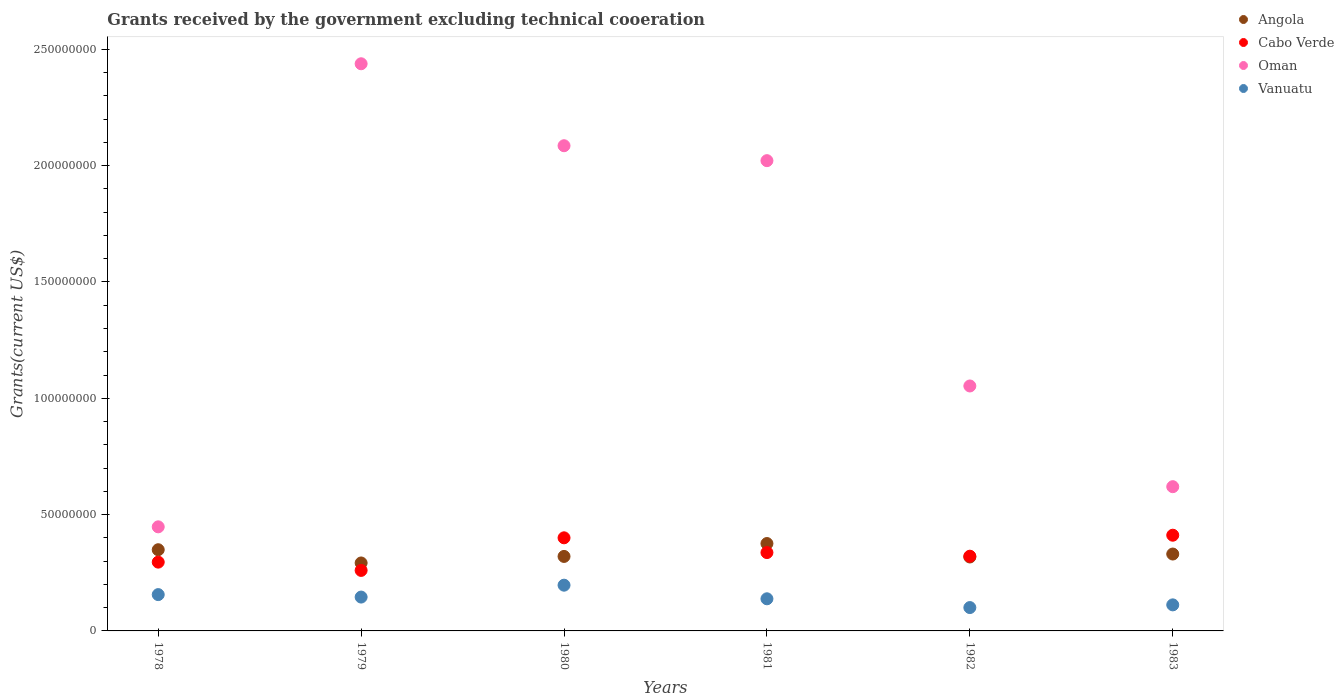What is the total grants received by the government in Vanuatu in 1979?
Give a very brief answer. 1.46e+07. Across all years, what is the maximum total grants received by the government in Vanuatu?
Keep it short and to the point. 1.97e+07. Across all years, what is the minimum total grants received by the government in Vanuatu?
Provide a short and direct response. 1.00e+07. In which year was the total grants received by the government in Cabo Verde maximum?
Your response must be concise. 1983. In which year was the total grants received by the government in Oman minimum?
Give a very brief answer. 1978. What is the total total grants received by the government in Vanuatu in the graph?
Ensure brevity in your answer.  8.49e+07. What is the difference between the total grants received by the government in Angola in 1979 and that in 1982?
Ensure brevity in your answer.  -2.57e+06. What is the difference between the total grants received by the government in Vanuatu in 1983 and the total grants received by the government in Oman in 1980?
Offer a terse response. -1.97e+08. What is the average total grants received by the government in Angola per year?
Provide a succinct answer. 3.31e+07. In the year 1979, what is the difference between the total grants received by the government in Vanuatu and total grants received by the government in Angola?
Give a very brief answer. -1.47e+07. In how many years, is the total grants received by the government in Angola greater than 140000000 US$?
Provide a short and direct response. 0. What is the ratio of the total grants received by the government in Oman in 1979 to that in 1981?
Your answer should be very brief. 1.21. Is the difference between the total grants received by the government in Vanuatu in 1980 and 1983 greater than the difference between the total grants received by the government in Angola in 1980 and 1983?
Provide a short and direct response. Yes. What is the difference between the highest and the second highest total grants received by the government in Vanuatu?
Provide a succinct answer. 4.05e+06. What is the difference between the highest and the lowest total grants received by the government in Vanuatu?
Your answer should be compact. 9.62e+06. In how many years, is the total grants received by the government in Oman greater than the average total grants received by the government in Oman taken over all years?
Give a very brief answer. 3. Is the sum of the total grants received by the government in Vanuatu in 1978 and 1982 greater than the maximum total grants received by the government in Cabo Verde across all years?
Your answer should be very brief. No. Is it the case that in every year, the sum of the total grants received by the government in Oman and total grants received by the government in Vanuatu  is greater than the total grants received by the government in Angola?
Give a very brief answer. Yes. How many dotlines are there?
Offer a very short reply. 4. How many years are there in the graph?
Keep it short and to the point. 6. Are the values on the major ticks of Y-axis written in scientific E-notation?
Provide a short and direct response. No. Does the graph contain grids?
Your answer should be very brief. No. What is the title of the graph?
Make the answer very short. Grants received by the government excluding technical cooeration. What is the label or title of the Y-axis?
Offer a terse response. Grants(current US$). What is the Grants(current US$) of Angola in 1978?
Keep it short and to the point. 3.49e+07. What is the Grants(current US$) of Cabo Verde in 1978?
Provide a succinct answer. 2.96e+07. What is the Grants(current US$) of Oman in 1978?
Your answer should be compact. 4.47e+07. What is the Grants(current US$) of Vanuatu in 1978?
Provide a succinct answer. 1.56e+07. What is the Grants(current US$) in Angola in 1979?
Your answer should be very brief. 2.92e+07. What is the Grants(current US$) of Cabo Verde in 1979?
Provide a short and direct response. 2.60e+07. What is the Grants(current US$) in Oman in 1979?
Keep it short and to the point. 2.44e+08. What is the Grants(current US$) of Vanuatu in 1979?
Your answer should be very brief. 1.46e+07. What is the Grants(current US$) in Angola in 1980?
Your answer should be compact. 3.20e+07. What is the Grants(current US$) in Cabo Verde in 1980?
Your answer should be compact. 4.00e+07. What is the Grants(current US$) in Oman in 1980?
Provide a succinct answer. 2.09e+08. What is the Grants(current US$) in Vanuatu in 1980?
Offer a terse response. 1.97e+07. What is the Grants(current US$) in Angola in 1981?
Your response must be concise. 3.76e+07. What is the Grants(current US$) in Cabo Verde in 1981?
Your answer should be very brief. 3.37e+07. What is the Grants(current US$) in Oman in 1981?
Ensure brevity in your answer.  2.02e+08. What is the Grants(current US$) of Vanuatu in 1981?
Provide a short and direct response. 1.38e+07. What is the Grants(current US$) of Angola in 1982?
Offer a very short reply. 3.18e+07. What is the Grants(current US$) in Cabo Verde in 1982?
Provide a short and direct response. 3.21e+07. What is the Grants(current US$) of Oman in 1982?
Your answer should be very brief. 1.05e+08. What is the Grants(current US$) of Vanuatu in 1982?
Your answer should be compact. 1.00e+07. What is the Grants(current US$) in Angola in 1983?
Your answer should be compact. 3.30e+07. What is the Grants(current US$) in Cabo Verde in 1983?
Offer a very short reply. 4.11e+07. What is the Grants(current US$) of Oman in 1983?
Provide a succinct answer. 6.20e+07. What is the Grants(current US$) of Vanuatu in 1983?
Provide a succinct answer. 1.12e+07. Across all years, what is the maximum Grants(current US$) in Angola?
Keep it short and to the point. 3.76e+07. Across all years, what is the maximum Grants(current US$) in Cabo Verde?
Make the answer very short. 4.11e+07. Across all years, what is the maximum Grants(current US$) of Oman?
Offer a terse response. 2.44e+08. Across all years, what is the maximum Grants(current US$) in Vanuatu?
Your answer should be very brief. 1.97e+07. Across all years, what is the minimum Grants(current US$) in Angola?
Your answer should be compact. 2.92e+07. Across all years, what is the minimum Grants(current US$) of Cabo Verde?
Your response must be concise. 2.60e+07. Across all years, what is the minimum Grants(current US$) of Oman?
Your answer should be compact. 4.47e+07. Across all years, what is the minimum Grants(current US$) in Vanuatu?
Your response must be concise. 1.00e+07. What is the total Grants(current US$) in Angola in the graph?
Provide a short and direct response. 1.99e+08. What is the total Grants(current US$) of Cabo Verde in the graph?
Offer a very short reply. 2.03e+08. What is the total Grants(current US$) in Oman in the graph?
Your answer should be compact. 8.67e+08. What is the total Grants(current US$) in Vanuatu in the graph?
Offer a very short reply. 8.49e+07. What is the difference between the Grants(current US$) of Angola in 1978 and that in 1979?
Your answer should be very brief. 5.69e+06. What is the difference between the Grants(current US$) of Cabo Verde in 1978 and that in 1979?
Provide a succinct answer. 3.56e+06. What is the difference between the Grants(current US$) in Oman in 1978 and that in 1979?
Your answer should be compact. -1.99e+08. What is the difference between the Grants(current US$) in Vanuatu in 1978 and that in 1979?
Offer a very short reply. 1.06e+06. What is the difference between the Grants(current US$) in Angola in 1978 and that in 1980?
Offer a terse response. 2.88e+06. What is the difference between the Grants(current US$) of Cabo Verde in 1978 and that in 1980?
Ensure brevity in your answer.  -1.04e+07. What is the difference between the Grants(current US$) in Oman in 1978 and that in 1980?
Offer a terse response. -1.64e+08. What is the difference between the Grants(current US$) of Vanuatu in 1978 and that in 1980?
Your answer should be very brief. -4.05e+06. What is the difference between the Grants(current US$) in Angola in 1978 and that in 1981?
Provide a succinct answer. -2.66e+06. What is the difference between the Grants(current US$) in Cabo Verde in 1978 and that in 1981?
Offer a terse response. -4.11e+06. What is the difference between the Grants(current US$) of Oman in 1978 and that in 1981?
Provide a short and direct response. -1.57e+08. What is the difference between the Grants(current US$) of Vanuatu in 1978 and that in 1981?
Keep it short and to the point. 1.80e+06. What is the difference between the Grants(current US$) in Angola in 1978 and that in 1982?
Make the answer very short. 3.12e+06. What is the difference between the Grants(current US$) in Cabo Verde in 1978 and that in 1982?
Make the answer very short. -2.55e+06. What is the difference between the Grants(current US$) in Oman in 1978 and that in 1982?
Offer a very short reply. -6.06e+07. What is the difference between the Grants(current US$) in Vanuatu in 1978 and that in 1982?
Ensure brevity in your answer.  5.57e+06. What is the difference between the Grants(current US$) in Angola in 1978 and that in 1983?
Give a very brief answer. 1.85e+06. What is the difference between the Grants(current US$) in Cabo Verde in 1978 and that in 1983?
Make the answer very short. -1.16e+07. What is the difference between the Grants(current US$) in Oman in 1978 and that in 1983?
Provide a short and direct response. -1.73e+07. What is the difference between the Grants(current US$) in Vanuatu in 1978 and that in 1983?
Your answer should be very brief. 4.41e+06. What is the difference between the Grants(current US$) in Angola in 1979 and that in 1980?
Keep it short and to the point. -2.81e+06. What is the difference between the Grants(current US$) of Cabo Verde in 1979 and that in 1980?
Provide a succinct answer. -1.40e+07. What is the difference between the Grants(current US$) in Oman in 1979 and that in 1980?
Ensure brevity in your answer.  3.52e+07. What is the difference between the Grants(current US$) of Vanuatu in 1979 and that in 1980?
Offer a very short reply. -5.11e+06. What is the difference between the Grants(current US$) in Angola in 1979 and that in 1981?
Keep it short and to the point. -8.35e+06. What is the difference between the Grants(current US$) of Cabo Verde in 1979 and that in 1981?
Offer a terse response. -7.67e+06. What is the difference between the Grants(current US$) in Oman in 1979 and that in 1981?
Give a very brief answer. 4.16e+07. What is the difference between the Grants(current US$) in Vanuatu in 1979 and that in 1981?
Provide a succinct answer. 7.40e+05. What is the difference between the Grants(current US$) in Angola in 1979 and that in 1982?
Your answer should be compact. -2.57e+06. What is the difference between the Grants(current US$) of Cabo Verde in 1979 and that in 1982?
Offer a terse response. -6.11e+06. What is the difference between the Grants(current US$) in Oman in 1979 and that in 1982?
Offer a very short reply. 1.38e+08. What is the difference between the Grants(current US$) of Vanuatu in 1979 and that in 1982?
Your answer should be very brief. 4.51e+06. What is the difference between the Grants(current US$) of Angola in 1979 and that in 1983?
Provide a short and direct response. -3.84e+06. What is the difference between the Grants(current US$) in Cabo Verde in 1979 and that in 1983?
Give a very brief answer. -1.51e+07. What is the difference between the Grants(current US$) in Oman in 1979 and that in 1983?
Make the answer very short. 1.82e+08. What is the difference between the Grants(current US$) in Vanuatu in 1979 and that in 1983?
Make the answer very short. 3.35e+06. What is the difference between the Grants(current US$) in Angola in 1980 and that in 1981?
Make the answer very short. -5.54e+06. What is the difference between the Grants(current US$) in Cabo Verde in 1980 and that in 1981?
Offer a very short reply. 6.34e+06. What is the difference between the Grants(current US$) of Oman in 1980 and that in 1981?
Keep it short and to the point. 6.42e+06. What is the difference between the Grants(current US$) in Vanuatu in 1980 and that in 1981?
Make the answer very short. 5.85e+06. What is the difference between the Grants(current US$) of Angola in 1980 and that in 1982?
Keep it short and to the point. 2.40e+05. What is the difference between the Grants(current US$) in Cabo Verde in 1980 and that in 1982?
Keep it short and to the point. 7.90e+06. What is the difference between the Grants(current US$) in Oman in 1980 and that in 1982?
Provide a short and direct response. 1.03e+08. What is the difference between the Grants(current US$) in Vanuatu in 1980 and that in 1982?
Make the answer very short. 9.62e+06. What is the difference between the Grants(current US$) of Angola in 1980 and that in 1983?
Offer a terse response. -1.03e+06. What is the difference between the Grants(current US$) of Cabo Verde in 1980 and that in 1983?
Give a very brief answer. -1.12e+06. What is the difference between the Grants(current US$) of Oman in 1980 and that in 1983?
Keep it short and to the point. 1.47e+08. What is the difference between the Grants(current US$) of Vanuatu in 1980 and that in 1983?
Ensure brevity in your answer.  8.46e+06. What is the difference between the Grants(current US$) in Angola in 1981 and that in 1982?
Offer a very short reply. 5.78e+06. What is the difference between the Grants(current US$) in Cabo Verde in 1981 and that in 1982?
Make the answer very short. 1.56e+06. What is the difference between the Grants(current US$) of Oman in 1981 and that in 1982?
Provide a succinct answer. 9.68e+07. What is the difference between the Grants(current US$) in Vanuatu in 1981 and that in 1982?
Your response must be concise. 3.77e+06. What is the difference between the Grants(current US$) of Angola in 1981 and that in 1983?
Keep it short and to the point. 4.51e+06. What is the difference between the Grants(current US$) in Cabo Verde in 1981 and that in 1983?
Make the answer very short. -7.46e+06. What is the difference between the Grants(current US$) in Oman in 1981 and that in 1983?
Offer a very short reply. 1.40e+08. What is the difference between the Grants(current US$) in Vanuatu in 1981 and that in 1983?
Your response must be concise. 2.61e+06. What is the difference between the Grants(current US$) in Angola in 1982 and that in 1983?
Keep it short and to the point. -1.27e+06. What is the difference between the Grants(current US$) of Cabo Verde in 1982 and that in 1983?
Your answer should be compact. -9.02e+06. What is the difference between the Grants(current US$) in Oman in 1982 and that in 1983?
Give a very brief answer. 4.33e+07. What is the difference between the Grants(current US$) in Vanuatu in 1982 and that in 1983?
Ensure brevity in your answer.  -1.16e+06. What is the difference between the Grants(current US$) of Angola in 1978 and the Grants(current US$) of Cabo Verde in 1979?
Keep it short and to the point. 8.89e+06. What is the difference between the Grants(current US$) in Angola in 1978 and the Grants(current US$) in Oman in 1979?
Your answer should be very brief. -2.09e+08. What is the difference between the Grants(current US$) of Angola in 1978 and the Grants(current US$) of Vanuatu in 1979?
Provide a succinct answer. 2.04e+07. What is the difference between the Grants(current US$) of Cabo Verde in 1978 and the Grants(current US$) of Oman in 1979?
Your answer should be compact. -2.14e+08. What is the difference between the Grants(current US$) of Cabo Verde in 1978 and the Grants(current US$) of Vanuatu in 1979?
Make the answer very short. 1.50e+07. What is the difference between the Grants(current US$) in Oman in 1978 and the Grants(current US$) in Vanuatu in 1979?
Your response must be concise. 3.02e+07. What is the difference between the Grants(current US$) of Angola in 1978 and the Grants(current US$) of Cabo Verde in 1980?
Ensure brevity in your answer.  -5.12e+06. What is the difference between the Grants(current US$) of Angola in 1978 and the Grants(current US$) of Oman in 1980?
Offer a terse response. -1.74e+08. What is the difference between the Grants(current US$) of Angola in 1978 and the Grants(current US$) of Vanuatu in 1980?
Offer a terse response. 1.52e+07. What is the difference between the Grants(current US$) of Cabo Verde in 1978 and the Grants(current US$) of Oman in 1980?
Your answer should be very brief. -1.79e+08. What is the difference between the Grants(current US$) of Cabo Verde in 1978 and the Grants(current US$) of Vanuatu in 1980?
Make the answer very short. 9.91e+06. What is the difference between the Grants(current US$) of Oman in 1978 and the Grants(current US$) of Vanuatu in 1980?
Provide a succinct answer. 2.51e+07. What is the difference between the Grants(current US$) of Angola in 1978 and the Grants(current US$) of Cabo Verde in 1981?
Offer a terse response. 1.22e+06. What is the difference between the Grants(current US$) of Angola in 1978 and the Grants(current US$) of Oman in 1981?
Your answer should be very brief. -1.67e+08. What is the difference between the Grants(current US$) in Angola in 1978 and the Grants(current US$) in Vanuatu in 1981?
Provide a short and direct response. 2.11e+07. What is the difference between the Grants(current US$) of Cabo Verde in 1978 and the Grants(current US$) of Oman in 1981?
Your answer should be very brief. -1.73e+08. What is the difference between the Grants(current US$) in Cabo Verde in 1978 and the Grants(current US$) in Vanuatu in 1981?
Offer a very short reply. 1.58e+07. What is the difference between the Grants(current US$) in Oman in 1978 and the Grants(current US$) in Vanuatu in 1981?
Offer a very short reply. 3.09e+07. What is the difference between the Grants(current US$) in Angola in 1978 and the Grants(current US$) in Cabo Verde in 1982?
Your answer should be compact. 2.78e+06. What is the difference between the Grants(current US$) of Angola in 1978 and the Grants(current US$) of Oman in 1982?
Your response must be concise. -7.04e+07. What is the difference between the Grants(current US$) of Angola in 1978 and the Grants(current US$) of Vanuatu in 1982?
Provide a succinct answer. 2.49e+07. What is the difference between the Grants(current US$) of Cabo Verde in 1978 and the Grants(current US$) of Oman in 1982?
Your answer should be very brief. -7.57e+07. What is the difference between the Grants(current US$) in Cabo Verde in 1978 and the Grants(current US$) in Vanuatu in 1982?
Give a very brief answer. 1.95e+07. What is the difference between the Grants(current US$) in Oman in 1978 and the Grants(current US$) in Vanuatu in 1982?
Offer a terse response. 3.47e+07. What is the difference between the Grants(current US$) in Angola in 1978 and the Grants(current US$) in Cabo Verde in 1983?
Ensure brevity in your answer.  -6.24e+06. What is the difference between the Grants(current US$) of Angola in 1978 and the Grants(current US$) of Oman in 1983?
Provide a short and direct response. -2.71e+07. What is the difference between the Grants(current US$) of Angola in 1978 and the Grants(current US$) of Vanuatu in 1983?
Your answer should be compact. 2.37e+07. What is the difference between the Grants(current US$) in Cabo Verde in 1978 and the Grants(current US$) in Oman in 1983?
Keep it short and to the point. -3.24e+07. What is the difference between the Grants(current US$) in Cabo Verde in 1978 and the Grants(current US$) in Vanuatu in 1983?
Ensure brevity in your answer.  1.84e+07. What is the difference between the Grants(current US$) in Oman in 1978 and the Grants(current US$) in Vanuatu in 1983?
Offer a terse response. 3.35e+07. What is the difference between the Grants(current US$) of Angola in 1979 and the Grants(current US$) of Cabo Verde in 1980?
Your answer should be very brief. -1.08e+07. What is the difference between the Grants(current US$) of Angola in 1979 and the Grants(current US$) of Oman in 1980?
Your response must be concise. -1.79e+08. What is the difference between the Grants(current US$) in Angola in 1979 and the Grants(current US$) in Vanuatu in 1980?
Provide a short and direct response. 9.55e+06. What is the difference between the Grants(current US$) in Cabo Verde in 1979 and the Grants(current US$) in Oman in 1980?
Your answer should be compact. -1.83e+08. What is the difference between the Grants(current US$) in Cabo Verde in 1979 and the Grants(current US$) in Vanuatu in 1980?
Ensure brevity in your answer.  6.35e+06. What is the difference between the Grants(current US$) in Oman in 1979 and the Grants(current US$) in Vanuatu in 1980?
Offer a very short reply. 2.24e+08. What is the difference between the Grants(current US$) in Angola in 1979 and the Grants(current US$) in Cabo Verde in 1981?
Your answer should be compact. -4.47e+06. What is the difference between the Grants(current US$) of Angola in 1979 and the Grants(current US$) of Oman in 1981?
Your response must be concise. -1.73e+08. What is the difference between the Grants(current US$) in Angola in 1979 and the Grants(current US$) in Vanuatu in 1981?
Keep it short and to the point. 1.54e+07. What is the difference between the Grants(current US$) of Cabo Verde in 1979 and the Grants(current US$) of Oman in 1981?
Provide a succinct answer. -1.76e+08. What is the difference between the Grants(current US$) in Cabo Verde in 1979 and the Grants(current US$) in Vanuatu in 1981?
Your answer should be very brief. 1.22e+07. What is the difference between the Grants(current US$) of Oman in 1979 and the Grants(current US$) of Vanuatu in 1981?
Your answer should be compact. 2.30e+08. What is the difference between the Grants(current US$) in Angola in 1979 and the Grants(current US$) in Cabo Verde in 1982?
Give a very brief answer. -2.91e+06. What is the difference between the Grants(current US$) of Angola in 1979 and the Grants(current US$) of Oman in 1982?
Your response must be concise. -7.61e+07. What is the difference between the Grants(current US$) in Angola in 1979 and the Grants(current US$) in Vanuatu in 1982?
Offer a terse response. 1.92e+07. What is the difference between the Grants(current US$) in Cabo Verde in 1979 and the Grants(current US$) in Oman in 1982?
Provide a succinct answer. -7.93e+07. What is the difference between the Grants(current US$) of Cabo Verde in 1979 and the Grants(current US$) of Vanuatu in 1982?
Ensure brevity in your answer.  1.60e+07. What is the difference between the Grants(current US$) of Oman in 1979 and the Grants(current US$) of Vanuatu in 1982?
Give a very brief answer. 2.34e+08. What is the difference between the Grants(current US$) in Angola in 1979 and the Grants(current US$) in Cabo Verde in 1983?
Ensure brevity in your answer.  -1.19e+07. What is the difference between the Grants(current US$) of Angola in 1979 and the Grants(current US$) of Oman in 1983?
Offer a very short reply. -3.28e+07. What is the difference between the Grants(current US$) in Angola in 1979 and the Grants(current US$) in Vanuatu in 1983?
Your answer should be compact. 1.80e+07. What is the difference between the Grants(current US$) of Cabo Verde in 1979 and the Grants(current US$) of Oman in 1983?
Give a very brief answer. -3.60e+07. What is the difference between the Grants(current US$) of Cabo Verde in 1979 and the Grants(current US$) of Vanuatu in 1983?
Make the answer very short. 1.48e+07. What is the difference between the Grants(current US$) in Oman in 1979 and the Grants(current US$) in Vanuatu in 1983?
Keep it short and to the point. 2.33e+08. What is the difference between the Grants(current US$) in Angola in 1980 and the Grants(current US$) in Cabo Verde in 1981?
Offer a very short reply. -1.66e+06. What is the difference between the Grants(current US$) in Angola in 1980 and the Grants(current US$) in Oman in 1981?
Your answer should be very brief. -1.70e+08. What is the difference between the Grants(current US$) in Angola in 1980 and the Grants(current US$) in Vanuatu in 1981?
Ensure brevity in your answer.  1.82e+07. What is the difference between the Grants(current US$) of Cabo Verde in 1980 and the Grants(current US$) of Oman in 1981?
Offer a terse response. -1.62e+08. What is the difference between the Grants(current US$) in Cabo Verde in 1980 and the Grants(current US$) in Vanuatu in 1981?
Provide a short and direct response. 2.62e+07. What is the difference between the Grants(current US$) of Oman in 1980 and the Grants(current US$) of Vanuatu in 1981?
Provide a short and direct response. 1.95e+08. What is the difference between the Grants(current US$) of Angola in 1980 and the Grants(current US$) of Cabo Verde in 1982?
Offer a very short reply. -1.00e+05. What is the difference between the Grants(current US$) of Angola in 1980 and the Grants(current US$) of Oman in 1982?
Offer a terse response. -7.33e+07. What is the difference between the Grants(current US$) in Angola in 1980 and the Grants(current US$) in Vanuatu in 1982?
Make the answer very short. 2.20e+07. What is the difference between the Grants(current US$) in Cabo Verde in 1980 and the Grants(current US$) in Oman in 1982?
Make the answer very short. -6.53e+07. What is the difference between the Grants(current US$) in Cabo Verde in 1980 and the Grants(current US$) in Vanuatu in 1982?
Your response must be concise. 3.00e+07. What is the difference between the Grants(current US$) in Oman in 1980 and the Grants(current US$) in Vanuatu in 1982?
Offer a terse response. 1.99e+08. What is the difference between the Grants(current US$) of Angola in 1980 and the Grants(current US$) of Cabo Verde in 1983?
Make the answer very short. -9.12e+06. What is the difference between the Grants(current US$) in Angola in 1980 and the Grants(current US$) in Oman in 1983?
Offer a terse response. -3.00e+07. What is the difference between the Grants(current US$) in Angola in 1980 and the Grants(current US$) in Vanuatu in 1983?
Keep it short and to the point. 2.08e+07. What is the difference between the Grants(current US$) in Cabo Verde in 1980 and the Grants(current US$) in Oman in 1983?
Your answer should be compact. -2.20e+07. What is the difference between the Grants(current US$) in Cabo Verde in 1980 and the Grants(current US$) in Vanuatu in 1983?
Your answer should be compact. 2.88e+07. What is the difference between the Grants(current US$) in Oman in 1980 and the Grants(current US$) in Vanuatu in 1983?
Provide a short and direct response. 1.97e+08. What is the difference between the Grants(current US$) in Angola in 1981 and the Grants(current US$) in Cabo Verde in 1982?
Ensure brevity in your answer.  5.44e+06. What is the difference between the Grants(current US$) in Angola in 1981 and the Grants(current US$) in Oman in 1982?
Your answer should be very brief. -6.77e+07. What is the difference between the Grants(current US$) in Angola in 1981 and the Grants(current US$) in Vanuatu in 1982?
Make the answer very short. 2.75e+07. What is the difference between the Grants(current US$) of Cabo Verde in 1981 and the Grants(current US$) of Oman in 1982?
Keep it short and to the point. -7.16e+07. What is the difference between the Grants(current US$) of Cabo Verde in 1981 and the Grants(current US$) of Vanuatu in 1982?
Offer a very short reply. 2.36e+07. What is the difference between the Grants(current US$) in Oman in 1981 and the Grants(current US$) in Vanuatu in 1982?
Offer a very short reply. 1.92e+08. What is the difference between the Grants(current US$) in Angola in 1981 and the Grants(current US$) in Cabo Verde in 1983?
Give a very brief answer. -3.58e+06. What is the difference between the Grants(current US$) in Angola in 1981 and the Grants(current US$) in Oman in 1983?
Offer a very short reply. -2.44e+07. What is the difference between the Grants(current US$) of Angola in 1981 and the Grants(current US$) of Vanuatu in 1983?
Make the answer very short. 2.64e+07. What is the difference between the Grants(current US$) in Cabo Verde in 1981 and the Grants(current US$) in Oman in 1983?
Your answer should be compact. -2.83e+07. What is the difference between the Grants(current US$) of Cabo Verde in 1981 and the Grants(current US$) of Vanuatu in 1983?
Ensure brevity in your answer.  2.25e+07. What is the difference between the Grants(current US$) of Oman in 1981 and the Grants(current US$) of Vanuatu in 1983?
Offer a very short reply. 1.91e+08. What is the difference between the Grants(current US$) of Angola in 1982 and the Grants(current US$) of Cabo Verde in 1983?
Provide a succinct answer. -9.36e+06. What is the difference between the Grants(current US$) of Angola in 1982 and the Grants(current US$) of Oman in 1983?
Provide a short and direct response. -3.02e+07. What is the difference between the Grants(current US$) in Angola in 1982 and the Grants(current US$) in Vanuatu in 1983?
Give a very brief answer. 2.06e+07. What is the difference between the Grants(current US$) in Cabo Verde in 1982 and the Grants(current US$) in Oman in 1983?
Your answer should be very brief. -2.99e+07. What is the difference between the Grants(current US$) of Cabo Verde in 1982 and the Grants(current US$) of Vanuatu in 1983?
Your response must be concise. 2.09e+07. What is the difference between the Grants(current US$) of Oman in 1982 and the Grants(current US$) of Vanuatu in 1983?
Provide a short and direct response. 9.41e+07. What is the average Grants(current US$) in Angola per year?
Give a very brief answer. 3.31e+07. What is the average Grants(current US$) in Cabo Verde per year?
Give a very brief answer. 3.38e+07. What is the average Grants(current US$) of Oman per year?
Your answer should be very brief. 1.44e+08. What is the average Grants(current US$) in Vanuatu per year?
Offer a very short reply. 1.41e+07. In the year 1978, what is the difference between the Grants(current US$) of Angola and Grants(current US$) of Cabo Verde?
Your response must be concise. 5.33e+06. In the year 1978, what is the difference between the Grants(current US$) in Angola and Grants(current US$) in Oman?
Offer a very short reply. -9.84e+06. In the year 1978, what is the difference between the Grants(current US$) of Angola and Grants(current US$) of Vanuatu?
Offer a very short reply. 1.93e+07. In the year 1978, what is the difference between the Grants(current US$) of Cabo Verde and Grants(current US$) of Oman?
Your response must be concise. -1.52e+07. In the year 1978, what is the difference between the Grants(current US$) in Cabo Verde and Grants(current US$) in Vanuatu?
Your response must be concise. 1.40e+07. In the year 1978, what is the difference between the Grants(current US$) in Oman and Grants(current US$) in Vanuatu?
Make the answer very short. 2.91e+07. In the year 1979, what is the difference between the Grants(current US$) in Angola and Grants(current US$) in Cabo Verde?
Make the answer very short. 3.20e+06. In the year 1979, what is the difference between the Grants(current US$) of Angola and Grants(current US$) of Oman?
Your response must be concise. -2.15e+08. In the year 1979, what is the difference between the Grants(current US$) of Angola and Grants(current US$) of Vanuatu?
Your answer should be very brief. 1.47e+07. In the year 1979, what is the difference between the Grants(current US$) in Cabo Verde and Grants(current US$) in Oman?
Offer a terse response. -2.18e+08. In the year 1979, what is the difference between the Grants(current US$) in Cabo Verde and Grants(current US$) in Vanuatu?
Ensure brevity in your answer.  1.15e+07. In the year 1979, what is the difference between the Grants(current US$) of Oman and Grants(current US$) of Vanuatu?
Provide a succinct answer. 2.29e+08. In the year 1980, what is the difference between the Grants(current US$) in Angola and Grants(current US$) in Cabo Verde?
Your answer should be very brief. -8.00e+06. In the year 1980, what is the difference between the Grants(current US$) of Angola and Grants(current US$) of Oman?
Make the answer very short. -1.77e+08. In the year 1980, what is the difference between the Grants(current US$) of Angola and Grants(current US$) of Vanuatu?
Make the answer very short. 1.24e+07. In the year 1980, what is the difference between the Grants(current US$) of Cabo Verde and Grants(current US$) of Oman?
Your answer should be compact. -1.69e+08. In the year 1980, what is the difference between the Grants(current US$) of Cabo Verde and Grants(current US$) of Vanuatu?
Make the answer very short. 2.04e+07. In the year 1980, what is the difference between the Grants(current US$) in Oman and Grants(current US$) in Vanuatu?
Ensure brevity in your answer.  1.89e+08. In the year 1981, what is the difference between the Grants(current US$) of Angola and Grants(current US$) of Cabo Verde?
Your answer should be compact. 3.88e+06. In the year 1981, what is the difference between the Grants(current US$) in Angola and Grants(current US$) in Oman?
Offer a very short reply. -1.65e+08. In the year 1981, what is the difference between the Grants(current US$) in Angola and Grants(current US$) in Vanuatu?
Make the answer very short. 2.38e+07. In the year 1981, what is the difference between the Grants(current US$) of Cabo Verde and Grants(current US$) of Oman?
Your response must be concise. -1.68e+08. In the year 1981, what is the difference between the Grants(current US$) in Cabo Verde and Grants(current US$) in Vanuatu?
Ensure brevity in your answer.  1.99e+07. In the year 1981, what is the difference between the Grants(current US$) in Oman and Grants(current US$) in Vanuatu?
Make the answer very short. 1.88e+08. In the year 1982, what is the difference between the Grants(current US$) in Angola and Grants(current US$) in Oman?
Your response must be concise. -7.35e+07. In the year 1982, what is the difference between the Grants(current US$) in Angola and Grants(current US$) in Vanuatu?
Offer a terse response. 2.17e+07. In the year 1982, what is the difference between the Grants(current US$) in Cabo Verde and Grants(current US$) in Oman?
Ensure brevity in your answer.  -7.32e+07. In the year 1982, what is the difference between the Grants(current US$) of Cabo Verde and Grants(current US$) of Vanuatu?
Offer a very short reply. 2.21e+07. In the year 1982, what is the difference between the Grants(current US$) of Oman and Grants(current US$) of Vanuatu?
Make the answer very short. 9.52e+07. In the year 1983, what is the difference between the Grants(current US$) of Angola and Grants(current US$) of Cabo Verde?
Your answer should be compact. -8.09e+06. In the year 1983, what is the difference between the Grants(current US$) of Angola and Grants(current US$) of Oman?
Give a very brief answer. -2.90e+07. In the year 1983, what is the difference between the Grants(current US$) in Angola and Grants(current US$) in Vanuatu?
Make the answer very short. 2.18e+07. In the year 1983, what is the difference between the Grants(current US$) in Cabo Verde and Grants(current US$) in Oman?
Your answer should be very brief. -2.09e+07. In the year 1983, what is the difference between the Grants(current US$) of Cabo Verde and Grants(current US$) of Vanuatu?
Provide a succinct answer. 2.99e+07. In the year 1983, what is the difference between the Grants(current US$) in Oman and Grants(current US$) in Vanuatu?
Ensure brevity in your answer.  5.08e+07. What is the ratio of the Grants(current US$) of Angola in 1978 to that in 1979?
Provide a succinct answer. 1.19. What is the ratio of the Grants(current US$) in Cabo Verde in 1978 to that in 1979?
Provide a succinct answer. 1.14. What is the ratio of the Grants(current US$) of Oman in 1978 to that in 1979?
Provide a succinct answer. 0.18. What is the ratio of the Grants(current US$) of Vanuatu in 1978 to that in 1979?
Give a very brief answer. 1.07. What is the ratio of the Grants(current US$) of Angola in 1978 to that in 1980?
Your answer should be very brief. 1.09. What is the ratio of the Grants(current US$) in Cabo Verde in 1978 to that in 1980?
Offer a terse response. 0.74. What is the ratio of the Grants(current US$) in Oman in 1978 to that in 1980?
Your answer should be compact. 0.21. What is the ratio of the Grants(current US$) in Vanuatu in 1978 to that in 1980?
Ensure brevity in your answer.  0.79. What is the ratio of the Grants(current US$) in Angola in 1978 to that in 1981?
Your response must be concise. 0.93. What is the ratio of the Grants(current US$) of Cabo Verde in 1978 to that in 1981?
Your response must be concise. 0.88. What is the ratio of the Grants(current US$) of Oman in 1978 to that in 1981?
Your answer should be very brief. 0.22. What is the ratio of the Grants(current US$) in Vanuatu in 1978 to that in 1981?
Offer a terse response. 1.13. What is the ratio of the Grants(current US$) in Angola in 1978 to that in 1982?
Keep it short and to the point. 1.1. What is the ratio of the Grants(current US$) in Cabo Verde in 1978 to that in 1982?
Give a very brief answer. 0.92. What is the ratio of the Grants(current US$) in Oman in 1978 to that in 1982?
Provide a short and direct response. 0.42. What is the ratio of the Grants(current US$) of Vanuatu in 1978 to that in 1982?
Ensure brevity in your answer.  1.55. What is the ratio of the Grants(current US$) in Angola in 1978 to that in 1983?
Offer a terse response. 1.06. What is the ratio of the Grants(current US$) in Cabo Verde in 1978 to that in 1983?
Your response must be concise. 0.72. What is the ratio of the Grants(current US$) of Oman in 1978 to that in 1983?
Make the answer very short. 0.72. What is the ratio of the Grants(current US$) in Vanuatu in 1978 to that in 1983?
Your response must be concise. 1.39. What is the ratio of the Grants(current US$) of Angola in 1979 to that in 1980?
Provide a succinct answer. 0.91. What is the ratio of the Grants(current US$) in Cabo Verde in 1979 to that in 1980?
Provide a short and direct response. 0.65. What is the ratio of the Grants(current US$) of Oman in 1979 to that in 1980?
Provide a succinct answer. 1.17. What is the ratio of the Grants(current US$) in Vanuatu in 1979 to that in 1980?
Keep it short and to the point. 0.74. What is the ratio of the Grants(current US$) of Angola in 1979 to that in 1981?
Offer a very short reply. 0.78. What is the ratio of the Grants(current US$) in Cabo Verde in 1979 to that in 1981?
Make the answer very short. 0.77. What is the ratio of the Grants(current US$) of Oman in 1979 to that in 1981?
Your answer should be compact. 1.21. What is the ratio of the Grants(current US$) of Vanuatu in 1979 to that in 1981?
Your response must be concise. 1.05. What is the ratio of the Grants(current US$) of Angola in 1979 to that in 1982?
Offer a very short reply. 0.92. What is the ratio of the Grants(current US$) of Cabo Verde in 1979 to that in 1982?
Offer a terse response. 0.81. What is the ratio of the Grants(current US$) of Oman in 1979 to that in 1982?
Keep it short and to the point. 2.32. What is the ratio of the Grants(current US$) of Vanuatu in 1979 to that in 1982?
Offer a terse response. 1.45. What is the ratio of the Grants(current US$) of Angola in 1979 to that in 1983?
Offer a very short reply. 0.88. What is the ratio of the Grants(current US$) of Cabo Verde in 1979 to that in 1983?
Offer a terse response. 0.63. What is the ratio of the Grants(current US$) of Oman in 1979 to that in 1983?
Give a very brief answer. 3.93. What is the ratio of the Grants(current US$) of Vanuatu in 1979 to that in 1983?
Offer a terse response. 1.3. What is the ratio of the Grants(current US$) of Angola in 1980 to that in 1981?
Offer a very short reply. 0.85. What is the ratio of the Grants(current US$) in Cabo Verde in 1980 to that in 1981?
Your response must be concise. 1.19. What is the ratio of the Grants(current US$) of Oman in 1980 to that in 1981?
Make the answer very short. 1.03. What is the ratio of the Grants(current US$) in Vanuatu in 1980 to that in 1981?
Your response must be concise. 1.42. What is the ratio of the Grants(current US$) in Angola in 1980 to that in 1982?
Keep it short and to the point. 1.01. What is the ratio of the Grants(current US$) in Cabo Verde in 1980 to that in 1982?
Make the answer very short. 1.25. What is the ratio of the Grants(current US$) of Oman in 1980 to that in 1982?
Provide a short and direct response. 1.98. What is the ratio of the Grants(current US$) of Vanuatu in 1980 to that in 1982?
Offer a terse response. 1.96. What is the ratio of the Grants(current US$) in Angola in 1980 to that in 1983?
Give a very brief answer. 0.97. What is the ratio of the Grants(current US$) in Cabo Verde in 1980 to that in 1983?
Your response must be concise. 0.97. What is the ratio of the Grants(current US$) of Oman in 1980 to that in 1983?
Provide a succinct answer. 3.36. What is the ratio of the Grants(current US$) in Vanuatu in 1980 to that in 1983?
Provide a short and direct response. 1.76. What is the ratio of the Grants(current US$) in Angola in 1981 to that in 1982?
Ensure brevity in your answer.  1.18. What is the ratio of the Grants(current US$) of Cabo Verde in 1981 to that in 1982?
Provide a short and direct response. 1.05. What is the ratio of the Grants(current US$) of Oman in 1981 to that in 1982?
Your answer should be very brief. 1.92. What is the ratio of the Grants(current US$) in Vanuatu in 1981 to that in 1982?
Your answer should be compact. 1.38. What is the ratio of the Grants(current US$) of Angola in 1981 to that in 1983?
Provide a succinct answer. 1.14. What is the ratio of the Grants(current US$) of Cabo Verde in 1981 to that in 1983?
Keep it short and to the point. 0.82. What is the ratio of the Grants(current US$) of Oman in 1981 to that in 1983?
Your answer should be compact. 3.26. What is the ratio of the Grants(current US$) in Vanuatu in 1981 to that in 1983?
Your answer should be compact. 1.23. What is the ratio of the Grants(current US$) in Angola in 1982 to that in 1983?
Offer a terse response. 0.96. What is the ratio of the Grants(current US$) of Cabo Verde in 1982 to that in 1983?
Give a very brief answer. 0.78. What is the ratio of the Grants(current US$) of Oman in 1982 to that in 1983?
Keep it short and to the point. 1.7. What is the ratio of the Grants(current US$) of Vanuatu in 1982 to that in 1983?
Give a very brief answer. 0.9. What is the difference between the highest and the second highest Grants(current US$) of Angola?
Make the answer very short. 2.66e+06. What is the difference between the highest and the second highest Grants(current US$) in Cabo Verde?
Provide a short and direct response. 1.12e+06. What is the difference between the highest and the second highest Grants(current US$) of Oman?
Offer a very short reply. 3.52e+07. What is the difference between the highest and the second highest Grants(current US$) in Vanuatu?
Provide a succinct answer. 4.05e+06. What is the difference between the highest and the lowest Grants(current US$) in Angola?
Offer a very short reply. 8.35e+06. What is the difference between the highest and the lowest Grants(current US$) of Cabo Verde?
Keep it short and to the point. 1.51e+07. What is the difference between the highest and the lowest Grants(current US$) of Oman?
Make the answer very short. 1.99e+08. What is the difference between the highest and the lowest Grants(current US$) of Vanuatu?
Keep it short and to the point. 9.62e+06. 